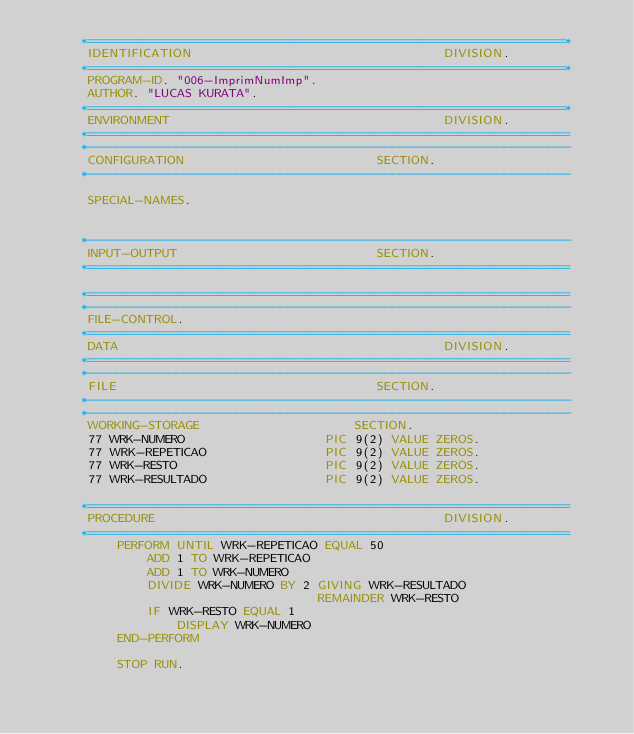<code> <loc_0><loc_0><loc_500><loc_500><_COBOL_>      *================================================================*
       IDENTIFICATION                                  DIVISION.
      *================================================================*
       PROGRAM-ID. "006-ImprimNumImp".
       AUTHOR. "LUCAS KURATA".
      *================================================================*
       ENVIRONMENT                                     DIVISION.
      *=================================================================
      *-----------------------------------------------------------------
       CONFIGURATION                          SECTION.
      *-----------------------------------------------------------------

       SPECIAL-NAMES.


      *-----------------------------------------------------------------
       INPUT-OUTPUT                           SECTION.
      *=================================================================

      *=================================================================
      *-----------------------------------------------------------------
       FILE-CONTROL.
      *=================================================================
       DATA                                            DIVISION.
      *=================================================================
      *-----------------------------------------------------------------
       FILE                                   SECTION.
      *-----------------------------------------------------------------
      *-----------------------------------------------------------------
       WORKING-STORAGE                     SECTION.
       77 WRK-NUMERO                   PIC 9(2) VALUE ZEROS.
       77 WRK-REPETICAO                PIC 9(2) VALUE ZEROS.
       77 WRK-RESTO                    PIC 9(2) VALUE ZEROS.
       77 WRK-RESULTADO                PIC 9(2) VALUE ZEROS.

      *=================================================================
       PROCEDURE                                       DIVISION.
      *=================================================================
           PERFORM UNTIL WRK-REPETICAO EQUAL 50
               ADD 1 TO WRK-REPETICAO
               ADD 1 TO WRK-NUMERO
               DIVIDE WRK-NUMERO BY 2 GIVING WRK-RESULTADO
                                      REMAINDER WRK-RESTO
               IF WRK-RESTO EQUAL 1
                   DISPLAY WRK-NUMERO
           END-PERFORM

           STOP RUN.
</code> 